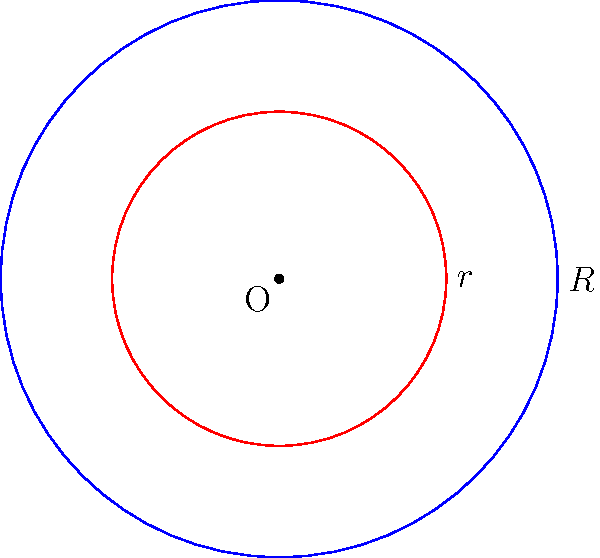As a school counselor, you're helping a student understand a geometry problem. Two concentric circles are shown, with the larger circle having a radius $R$ of 5 units and the smaller circle having a radius $r$ of 3 units. What is the area of the region between these two circles? Let's approach this step-by-step:

1) The area between two concentric circles is the difference between the areas of the larger and smaller circles.

2) The formula for the area of a circle is $A = \pi r^2$, where $r$ is the radius.

3) For the larger circle:
   Area = $\pi R^2 = \pi (5)^2 = 25\pi$ square units

4) For the smaller circle:
   Area = $\pi r^2 = \pi (3)^2 = 9\pi$ square units

5) The area between the circles is the difference:
   $25\pi - 9\pi = 16\pi$ square units

Therefore, the area of the region between the two concentric circles is $16\pi$ square units.
Answer: $16\pi$ square units 